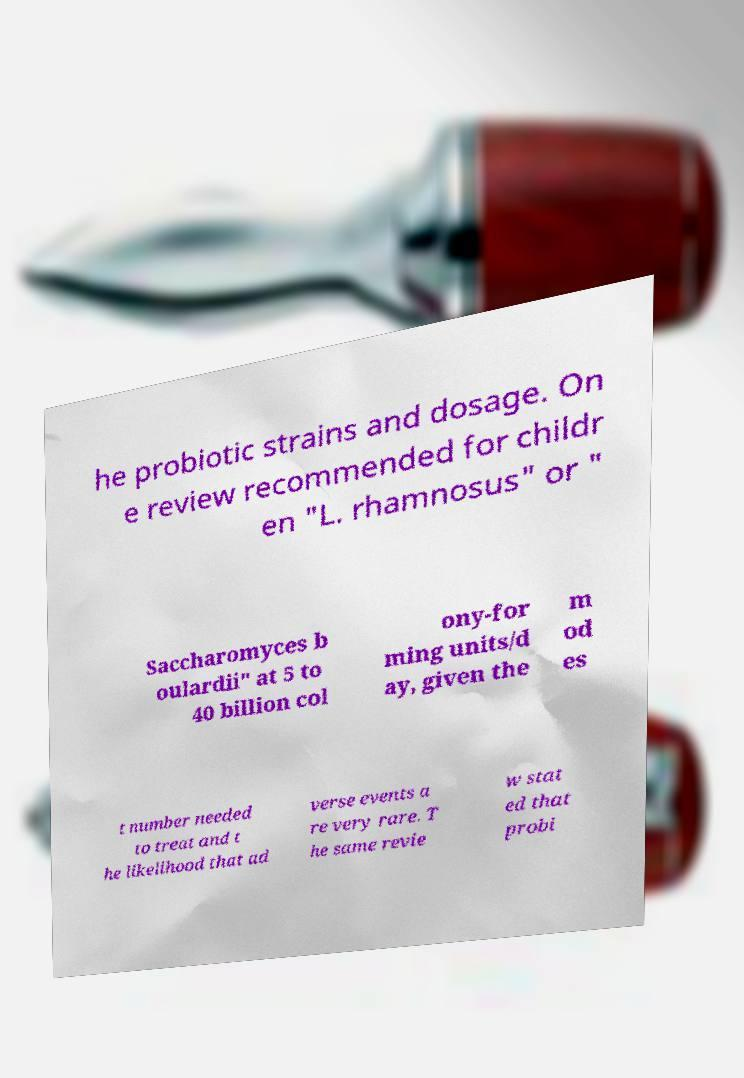Could you assist in decoding the text presented in this image and type it out clearly? he probiotic strains and dosage. On e review recommended for childr en "L. rhamnosus" or " Saccharomyces b oulardii" at 5 to 40 billion col ony-for ming units/d ay, given the m od es t number needed to treat and t he likelihood that ad verse events a re very rare. T he same revie w stat ed that probi 